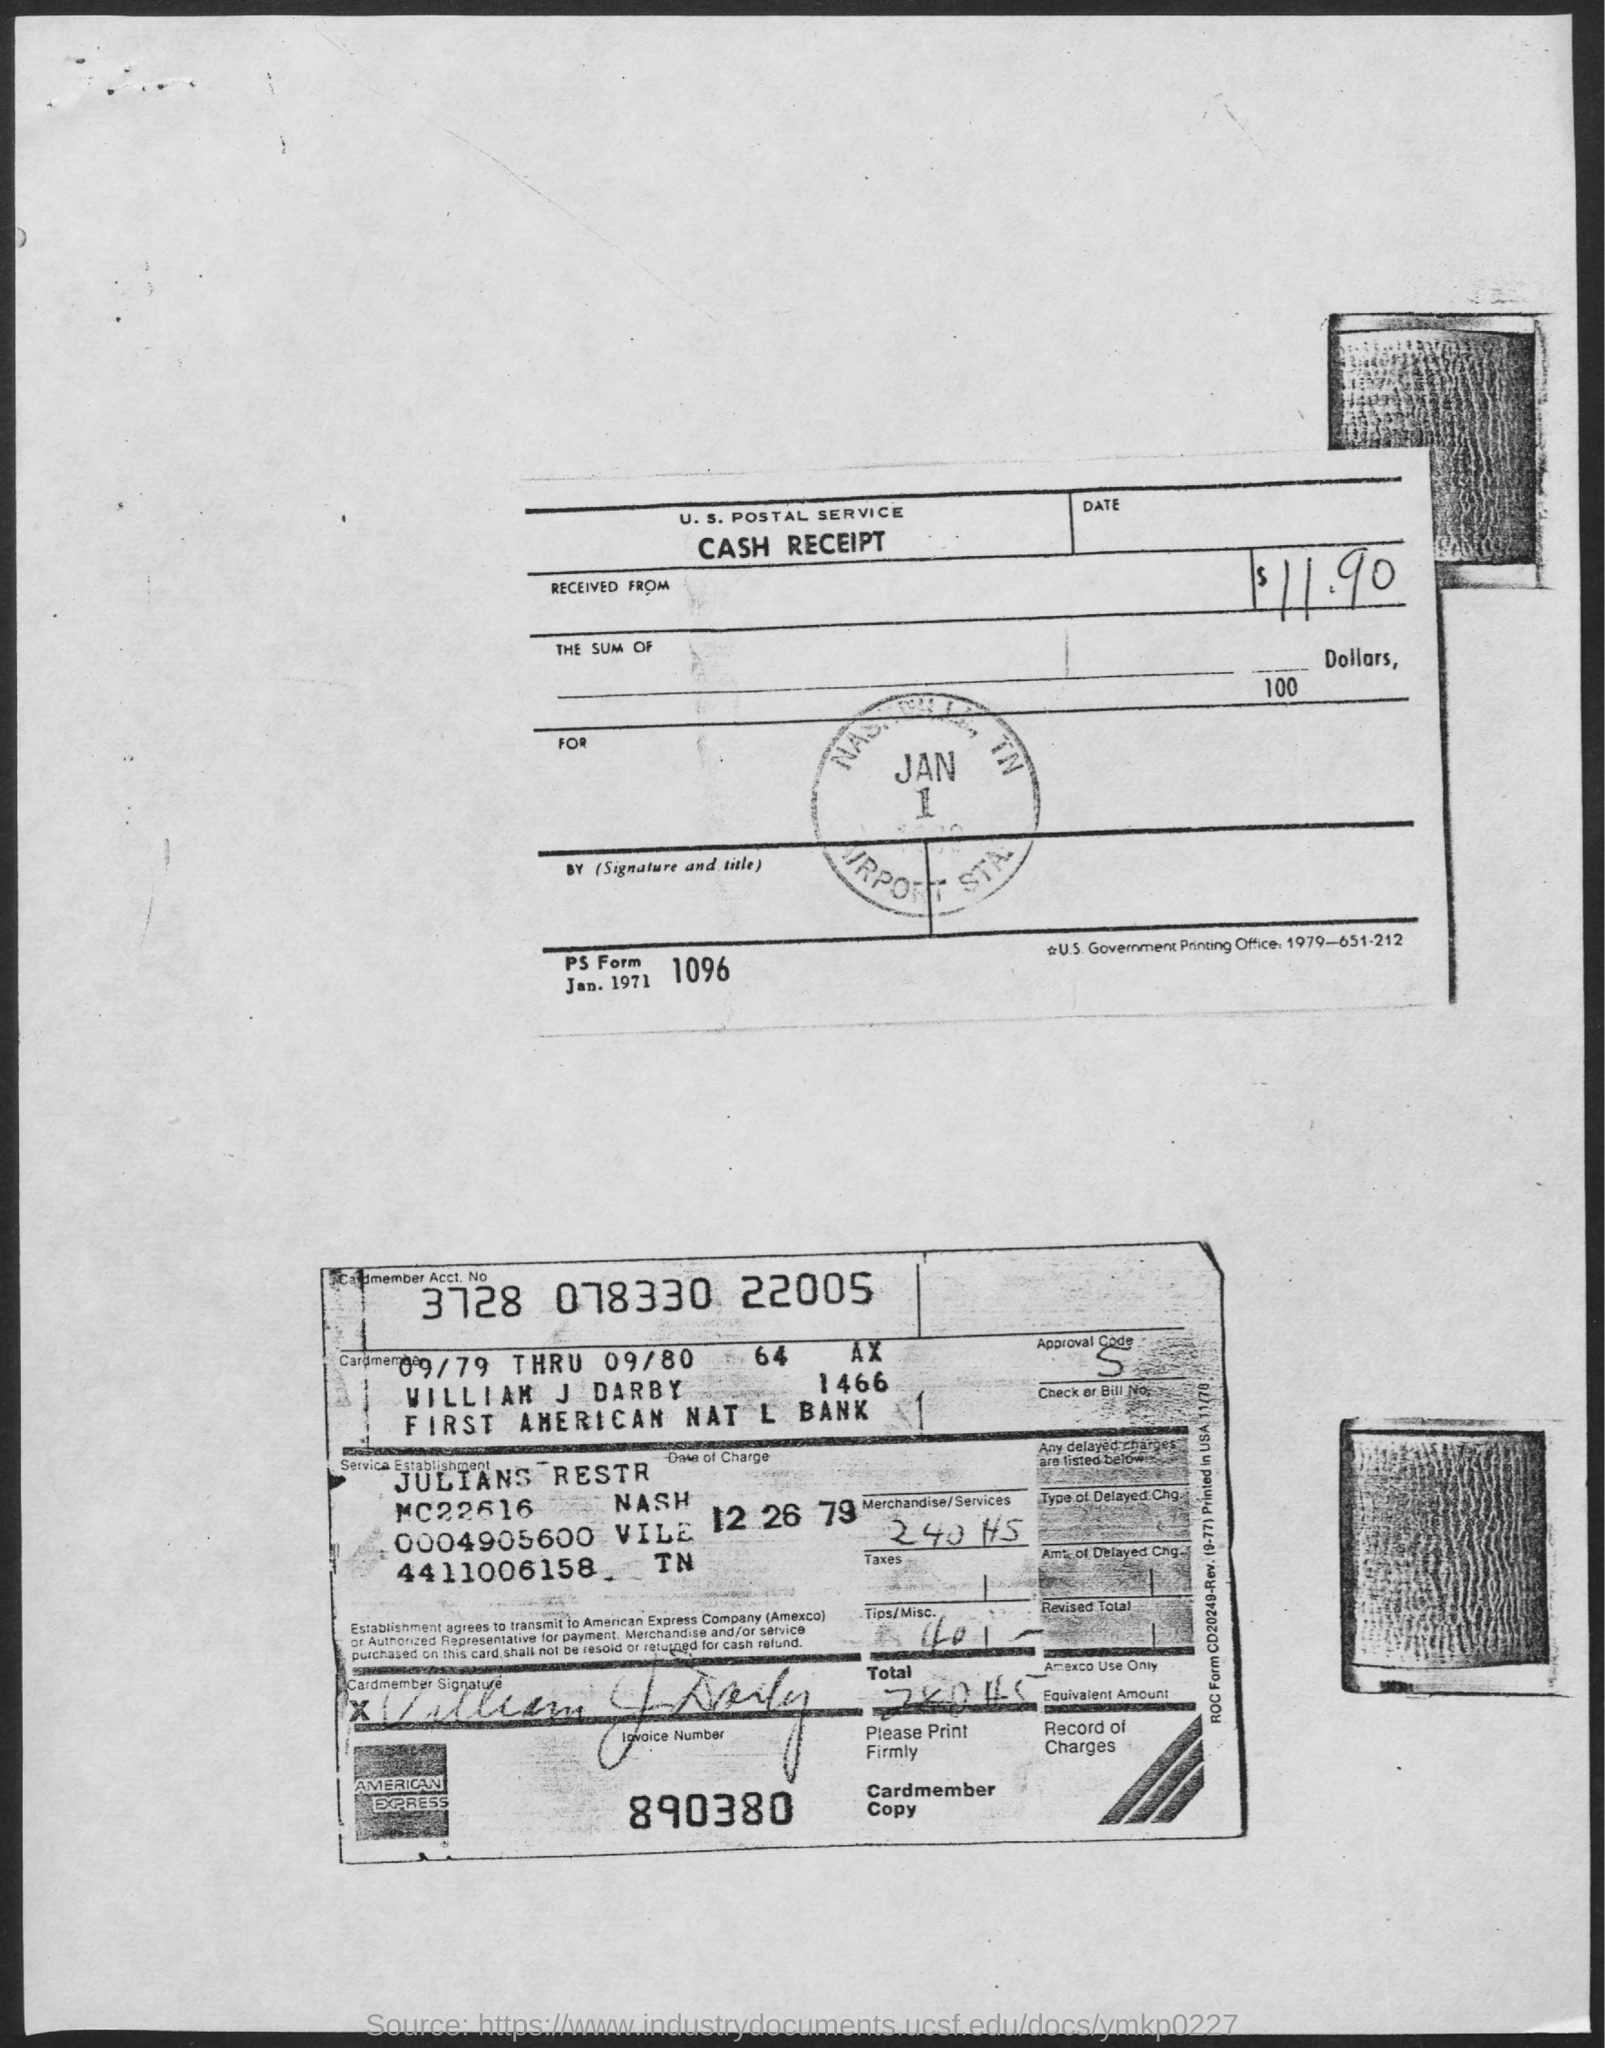What is the Title of the document?
Give a very brief answer. Cash Receipt. What is the amount?
Provide a succinct answer. $11.90. 